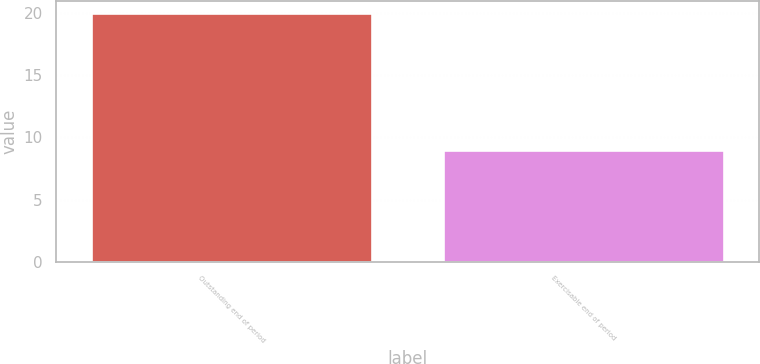<chart> <loc_0><loc_0><loc_500><loc_500><bar_chart><fcel>Outstanding end of period<fcel>Exercisable end of period<nl><fcel>20<fcel>9<nl></chart> 